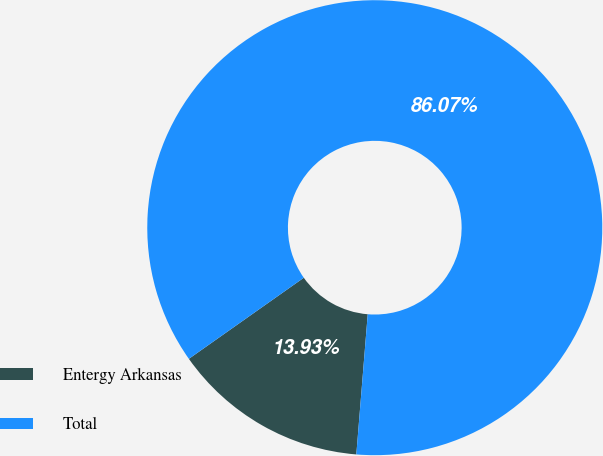<chart> <loc_0><loc_0><loc_500><loc_500><pie_chart><fcel>Entergy Arkansas<fcel>Total<nl><fcel>13.93%<fcel>86.07%<nl></chart> 